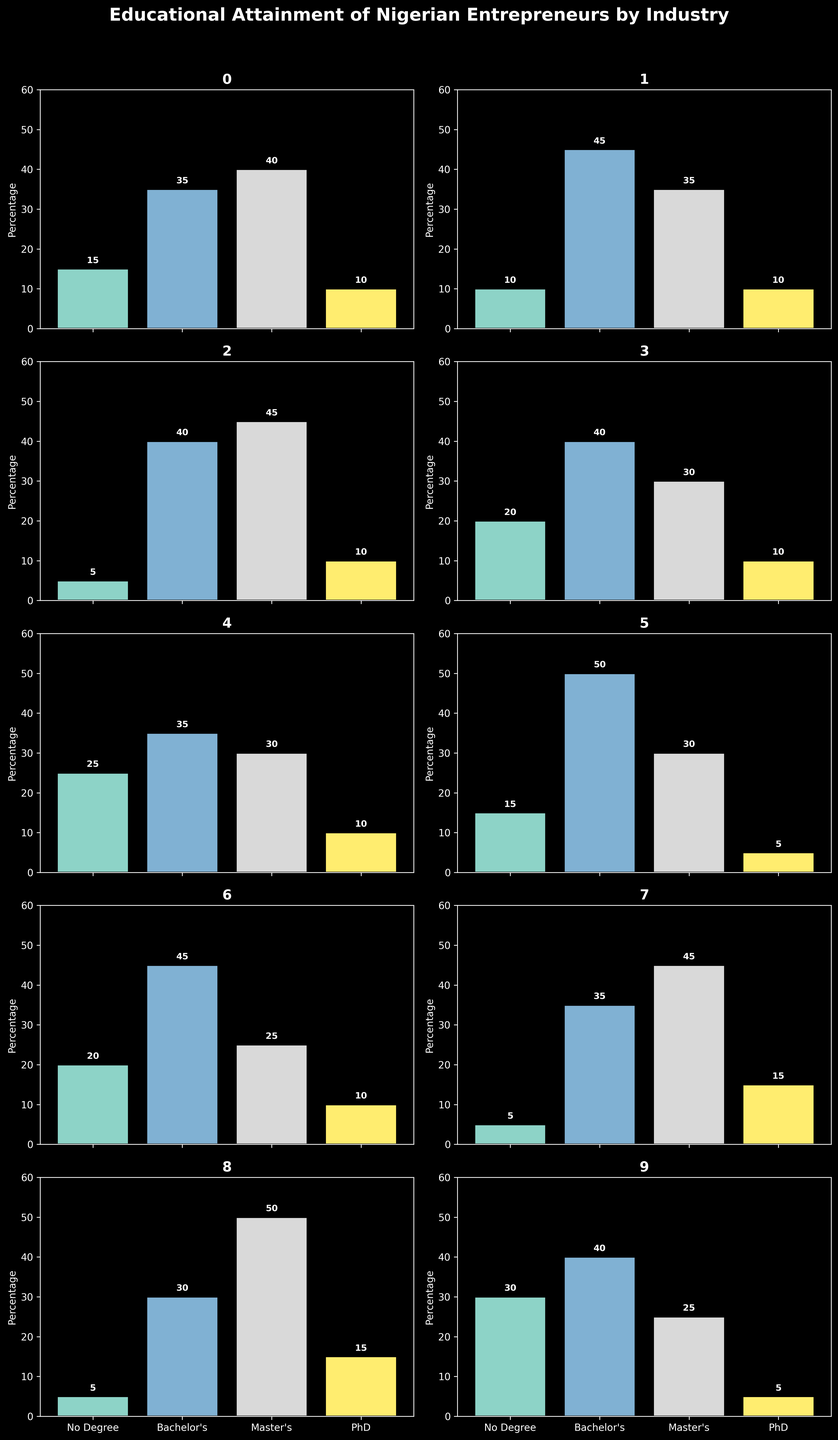Which industry has the highest percentage of entrepreneurs with a Bachelor's degree? By examining the figure, the Media industry shows the highest bar for the Bachelor's degree category.
Answer: Media Which industry has the lowest percentage of entrepreneurs with no degree? By looking at the figure, the Healthcare and Oil & Gas industries both have the lowest bar for the No Degree category.
Answer: Healthcare, Oil & Gas What is the total percentage of entrepreneurs with a Master's degree in Technology and Finance industries combined? In the Technology industry, 35% have a Master's degree, and in the Finance industry, 45% have a Master's degree. Summing these percentages gives 35 + 45 = 80.
Answer: 80% Which two industries have the same percentage of entrepreneurs with a PhD? By observing the bars for the PhD category, the Business, Technology, Finance, Manufacturing, Agriculture, and Real Estate industries all have the same percentage of 10%.
Answer: Business, Technology, Finance, Manufacturing, Agriculture, Real Estate How does the percentage of entrepreneurs with a Master's degree in Retail compare to that in Oil & Gas? The bar heights show that Retail has 25% with a Master's degree, while Oil & Gas has 45%. Since 25 is less than 45, Retail is lower.
Answer: Retail is lower What is the most common degree type among entrepreneurs in the Agriculture industry? By looking at the bar heights for different degree types, the highest bar in the Agriculture industry is for the No Degree category at 25%.
Answer: No Degree What is the average percentage of entrepreneurs with Bachelor's degrees across all industries? Summing the percentages for Bachelor's degrees across all industries: 35+45+40+40+35+50+45+35+30+40 = 395. Dividing this sum by 10 industries gives 395/10 = 39.5.
Answer: 39.5% If you sum the percentages of entrepreneurs with PhDs in the Business and Healthcare industries, what do you get? The Business industry has 10% and the Healthcare industry has 15% for PhDs. Summing these gives 10 + 15 = 25.
Answer: 25% Which industry has the highest total percentage of entrepreneurs with formal education (Bachelor's, Master's, or PhD)? By comparing the sum of percentages for Bachelor's, Master's, and PhD in each industry, the Healthcare industry has the highest total: 30 + 50 + 15 = 95.
Answer: Healthcare 